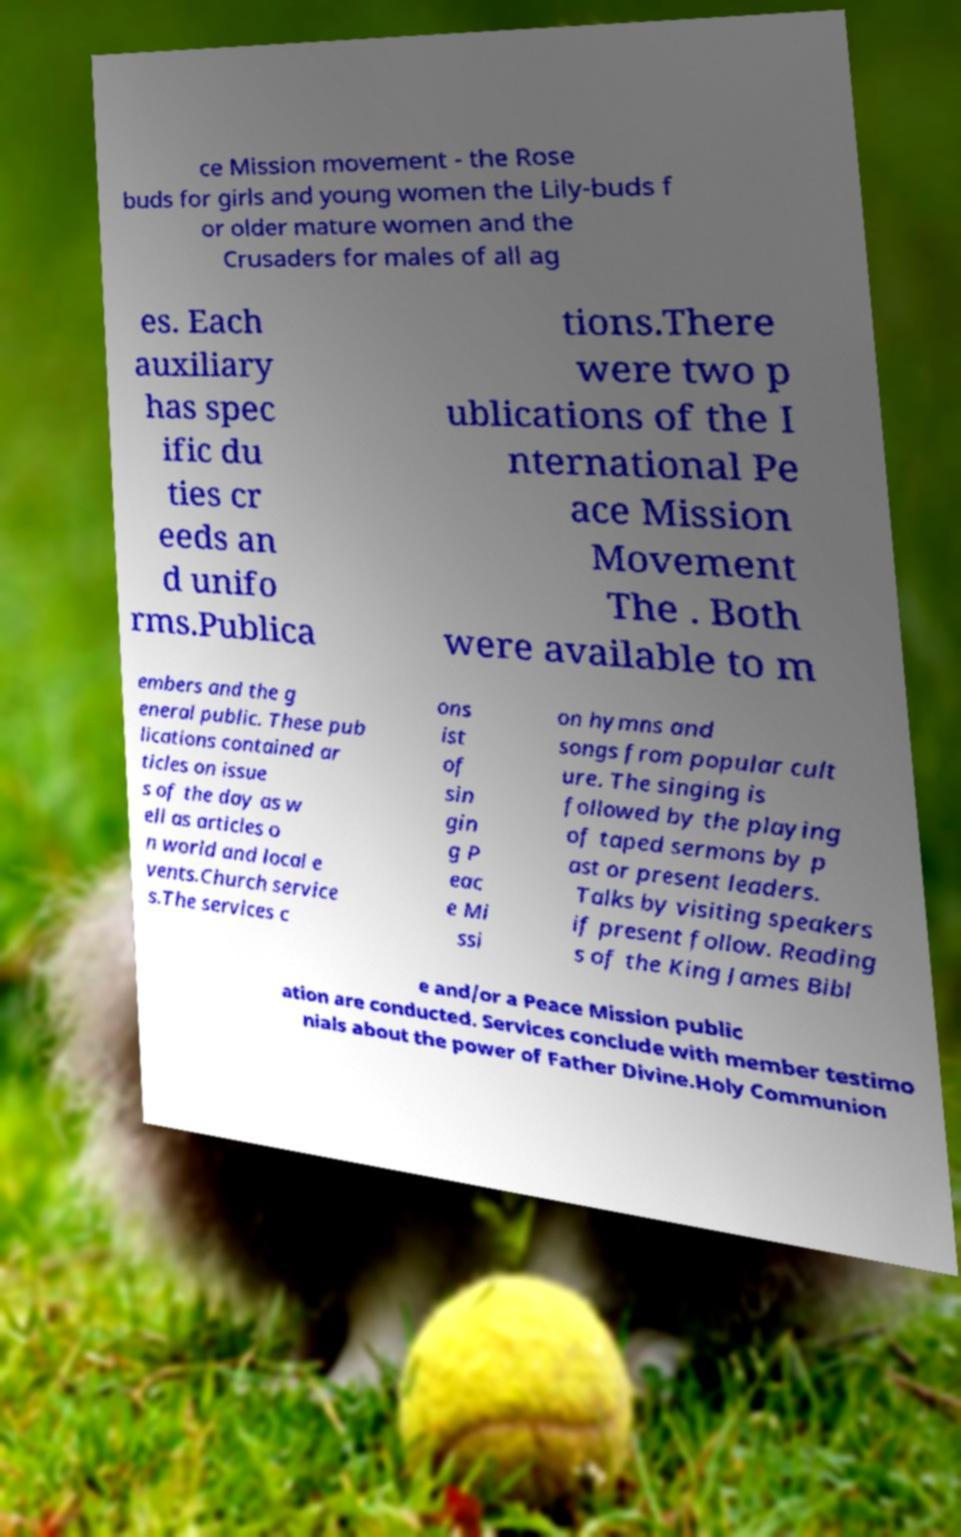Could you assist in decoding the text presented in this image and type it out clearly? ce Mission movement - the Rose buds for girls and young women the Lily-buds f or older mature women and the Crusaders for males of all ag es. Each auxiliary has spec ific du ties cr eeds an d unifo rms.Publica tions.There were two p ublications of the I nternational Pe ace Mission Movement The . Both were available to m embers and the g eneral public. These pub lications contained ar ticles on issue s of the day as w ell as articles o n world and local e vents.Church service s.The services c ons ist of sin gin g P eac e Mi ssi on hymns and songs from popular cult ure. The singing is followed by the playing of taped sermons by p ast or present leaders. Talks by visiting speakers if present follow. Reading s of the King James Bibl e and/or a Peace Mission public ation are conducted. Services conclude with member testimo nials about the power of Father Divine.Holy Communion 